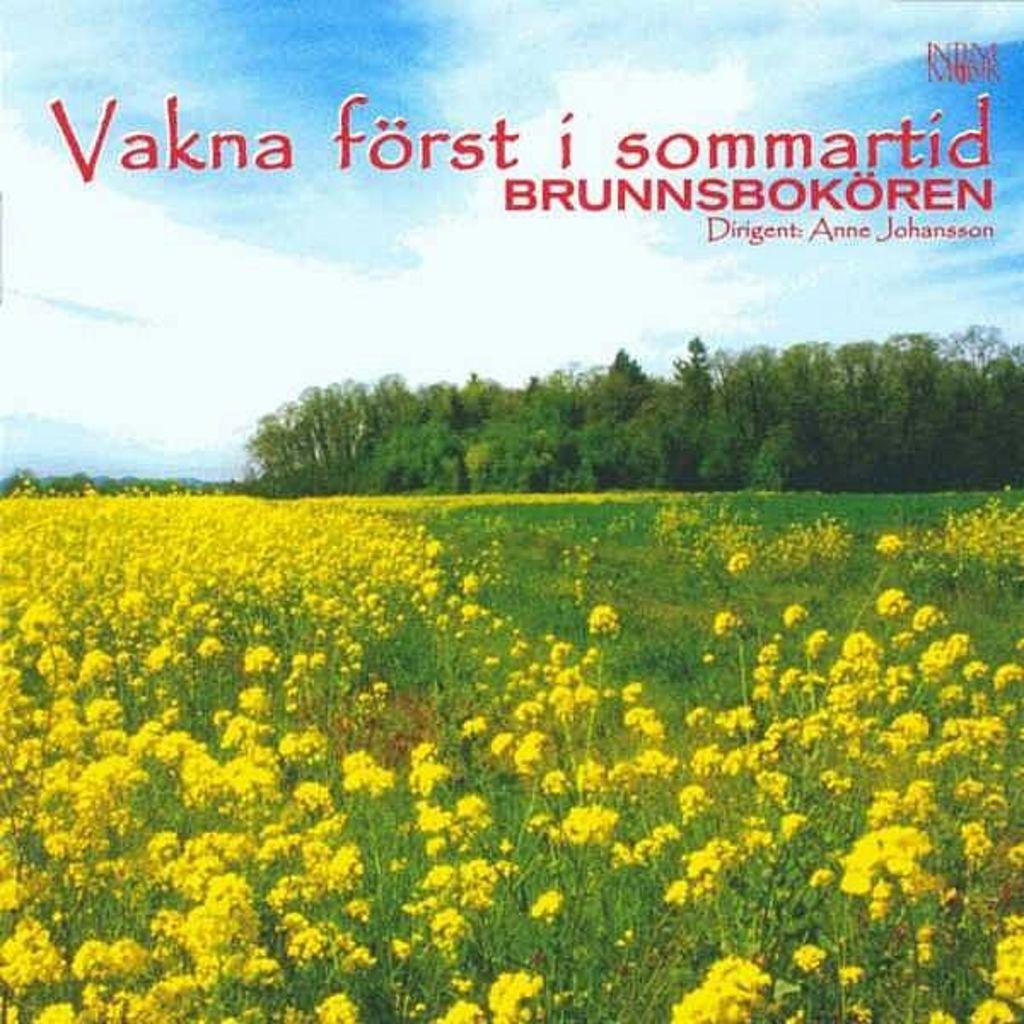How would you summarize this image in a sentence or two? In the picture I can see flower plants. These flowers are yellow in color. In the background I can see trees and watermarks on the image. 